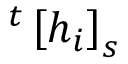Convert formula to latex. <formula><loc_0><loc_0><loc_500><loc_500>^ { t } \left [ h _ { i } \right ] _ { s }</formula> 